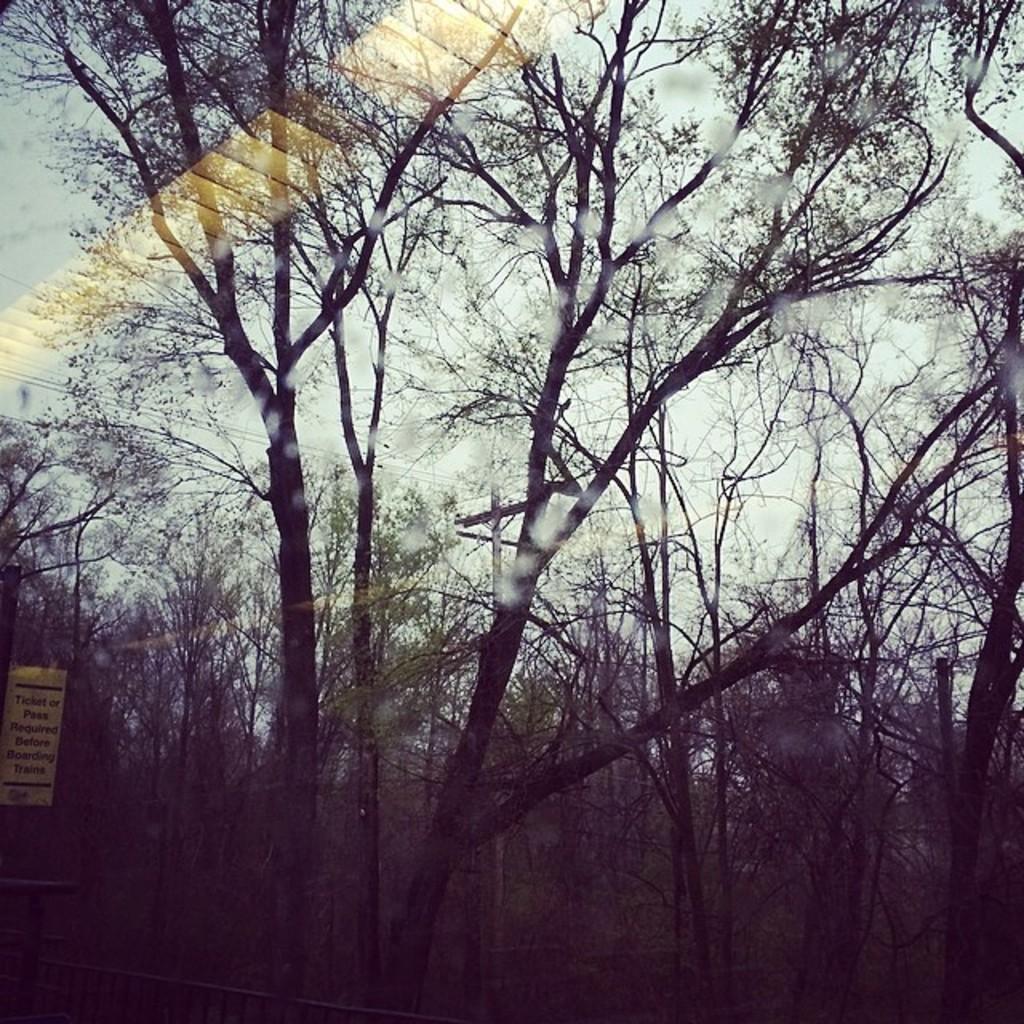In one or two sentences, can you explain what this image depicts? In this image we can see some trees, there are some wires connected to a pole, we can see a board with some text written on it, and also there is a fence. 